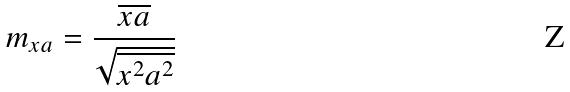Convert formula to latex. <formula><loc_0><loc_0><loc_500><loc_500>m _ { x a } = \frac { \overline { x a } } { \sqrt { \overline { x ^ { 2 } } \overline { a ^ { 2 } } } }</formula> 